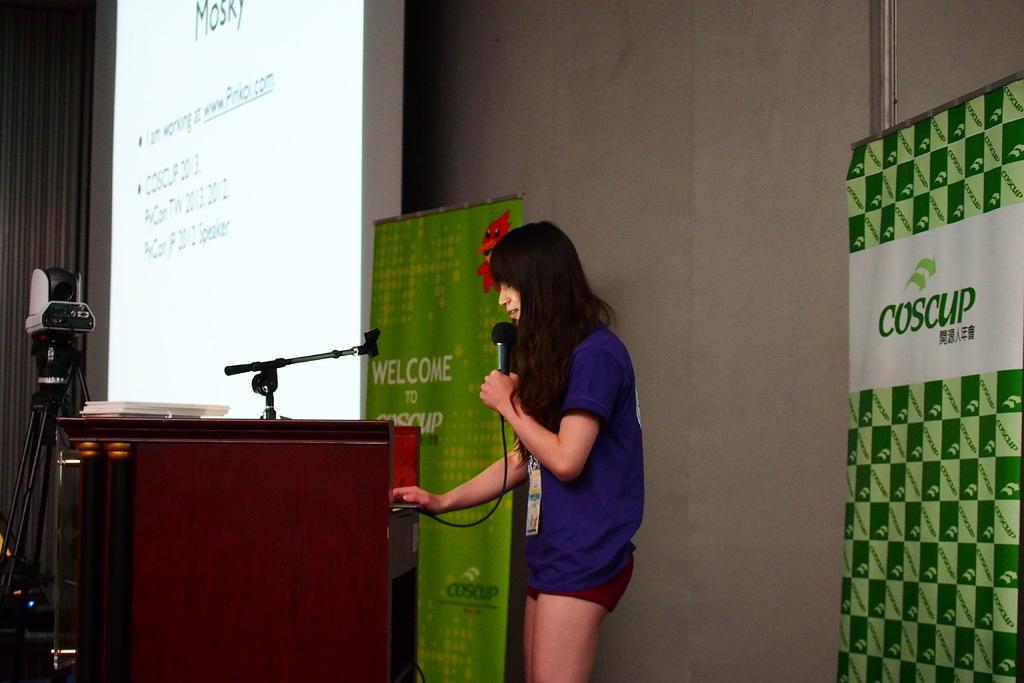Can you describe this image briefly? In this image we can see a woman standing holding a mic operating a device. We can also see a speaker stand containing a stand and some objects on it, a camera on a stand, a display screen and some banners with text on them and a wall. 